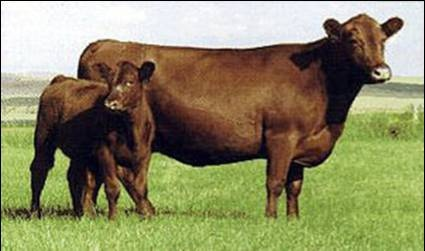Describe the objects in this image and their specific colors. I can see cow in black, maroon, and brown tones and cow in black, maroon, and gray tones in this image. 